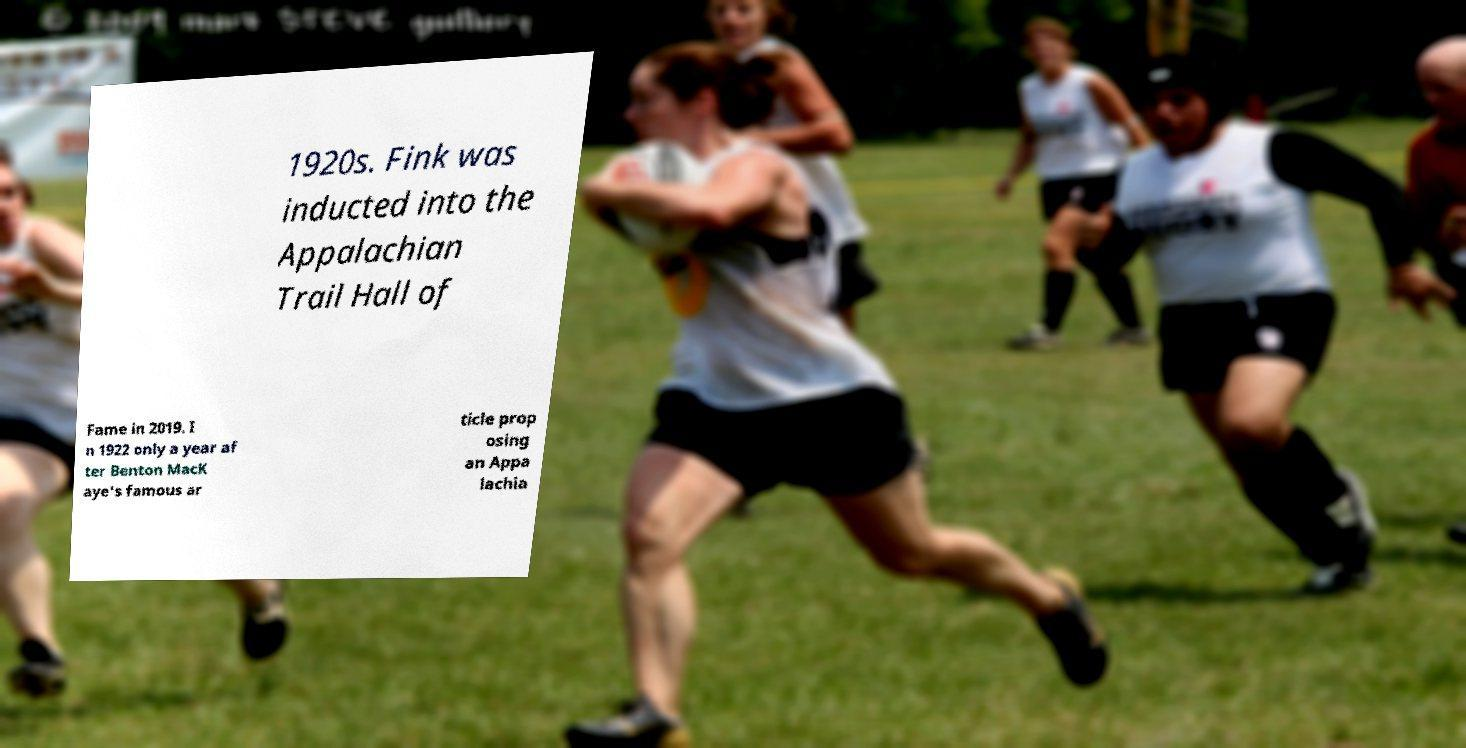I need the written content from this picture converted into text. Can you do that? 1920s. Fink was inducted into the Appalachian Trail Hall of Fame in 2019. I n 1922 only a year af ter Benton MacK aye's famous ar ticle prop osing an Appa lachia 